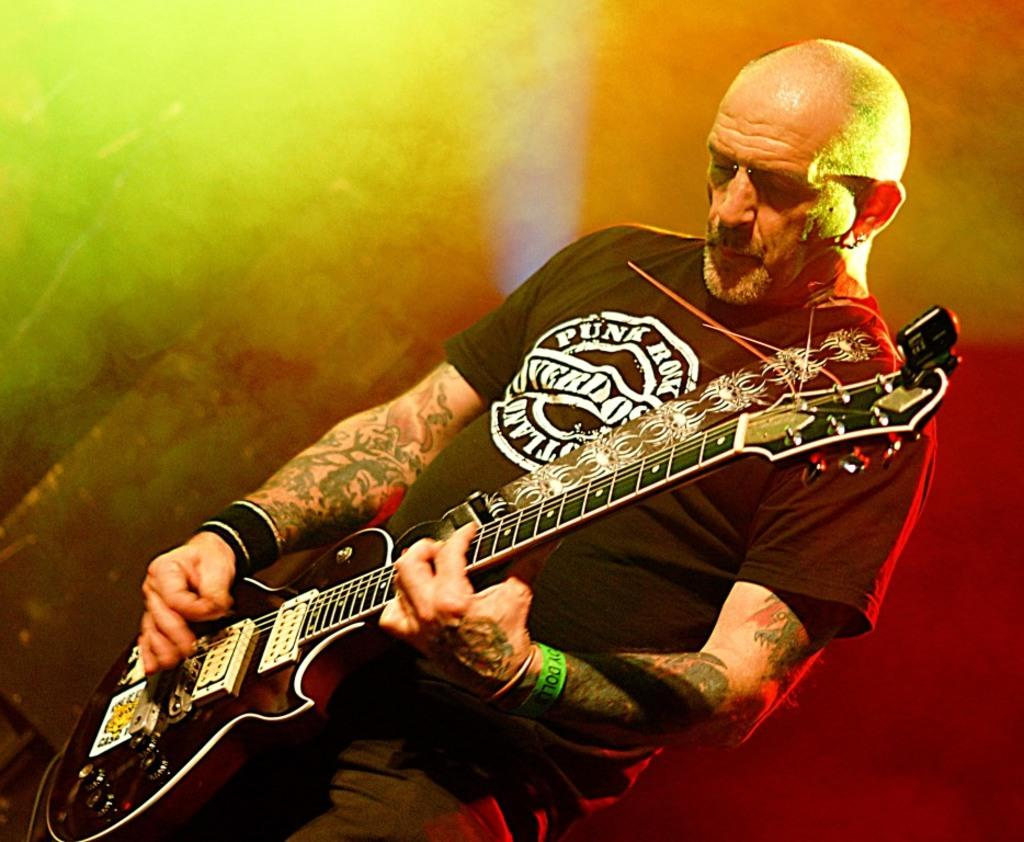What is the main subject of the image? There is a person in the image. What is the person wearing? The person is wearing a black dress. What is the person doing in the image? The person is standing and playing a guitar. What direction are the children walking in the image? There are no children present in the image. Is the person playing the guitar in the cellar? The provided facts do not mention the location of the person, so it cannot be determined if they are in a cellar. 